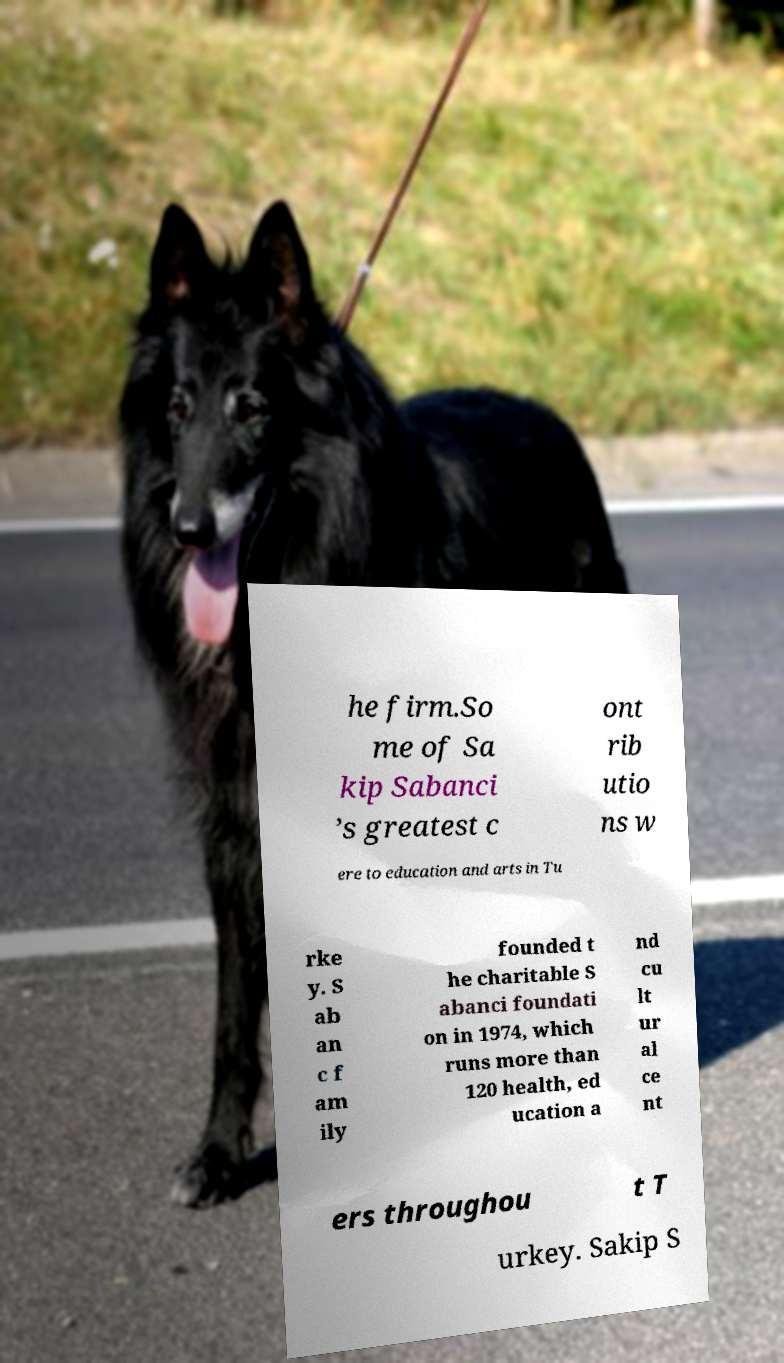Please read and relay the text visible in this image. What does it say? he firm.So me of Sa kip Sabanci ’s greatest c ont rib utio ns w ere to education and arts in Tu rke y. S ab an c f am ily founded t he charitable S abanci foundati on in 1974, which runs more than 120 health, ed ucation a nd cu lt ur al ce nt ers throughou t T urkey. Sakip S 